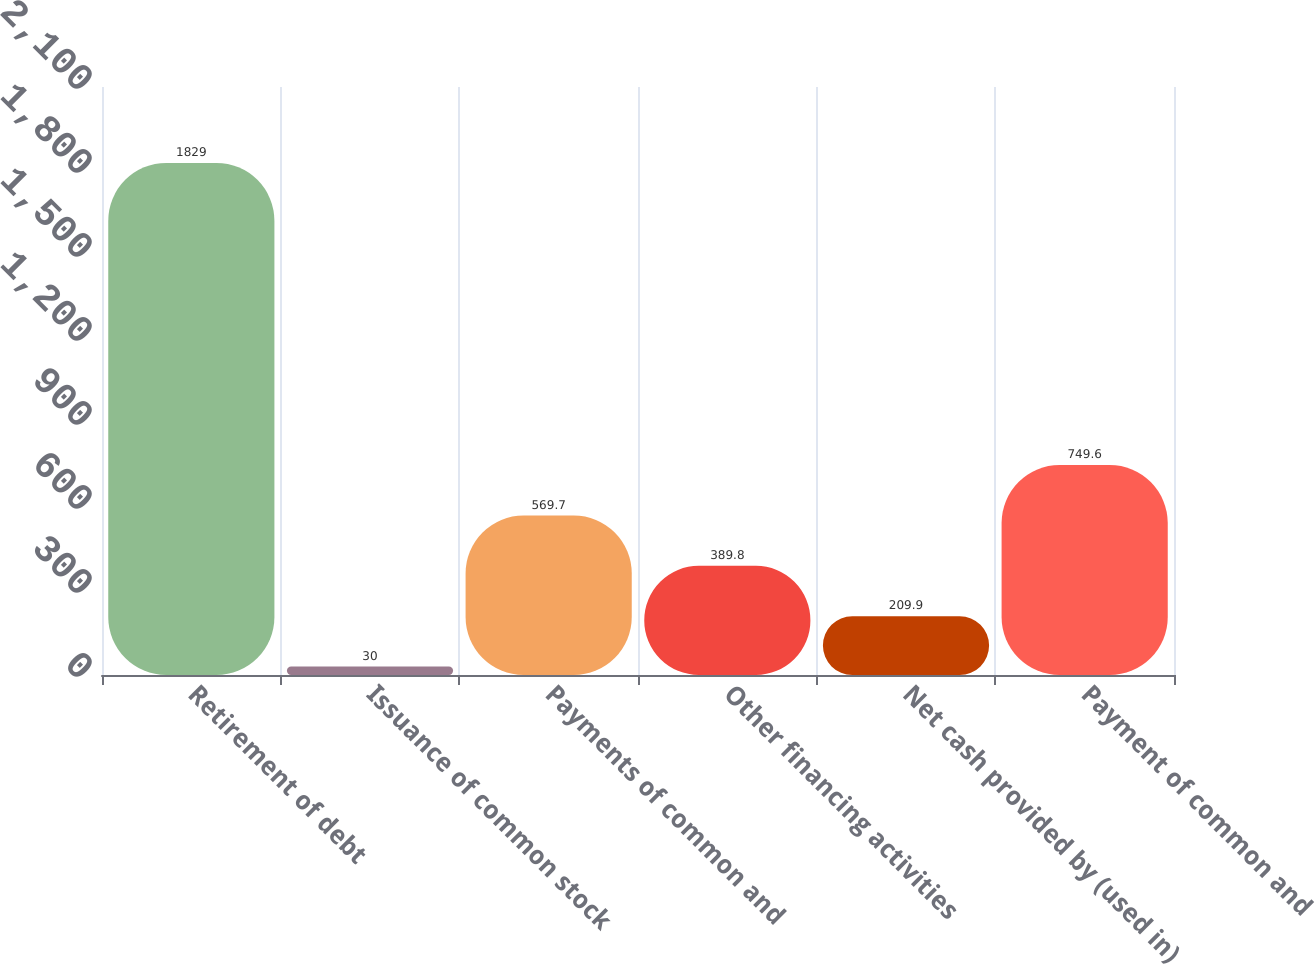Convert chart to OTSL. <chart><loc_0><loc_0><loc_500><loc_500><bar_chart><fcel>Retirement of debt<fcel>Issuance of common stock<fcel>Payments of common and<fcel>Other financing activities<fcel>Net cash provided by (used in)<fcel>Payment of common and<nl><fcel>1829<fcel>30<fcel>569.7<fcel>389.8<fcel>209.9<fcel>749.6<nl></chart> 